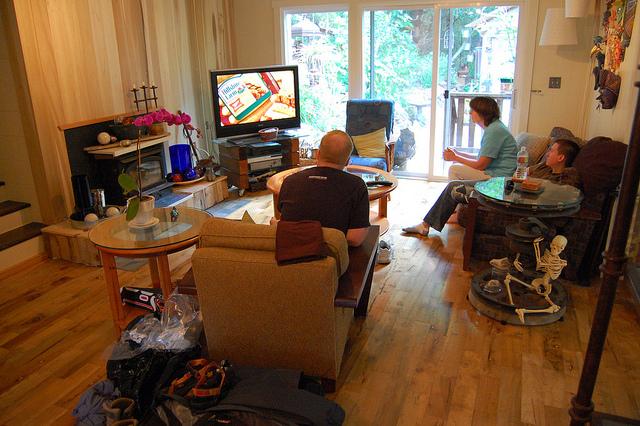What are the people watching?
Give a very brief answer. Tv. Where are the steps to go upstairs?
Keep it brief. Left. Is there a skeleton in this picture?
Short answer required. Yes. 